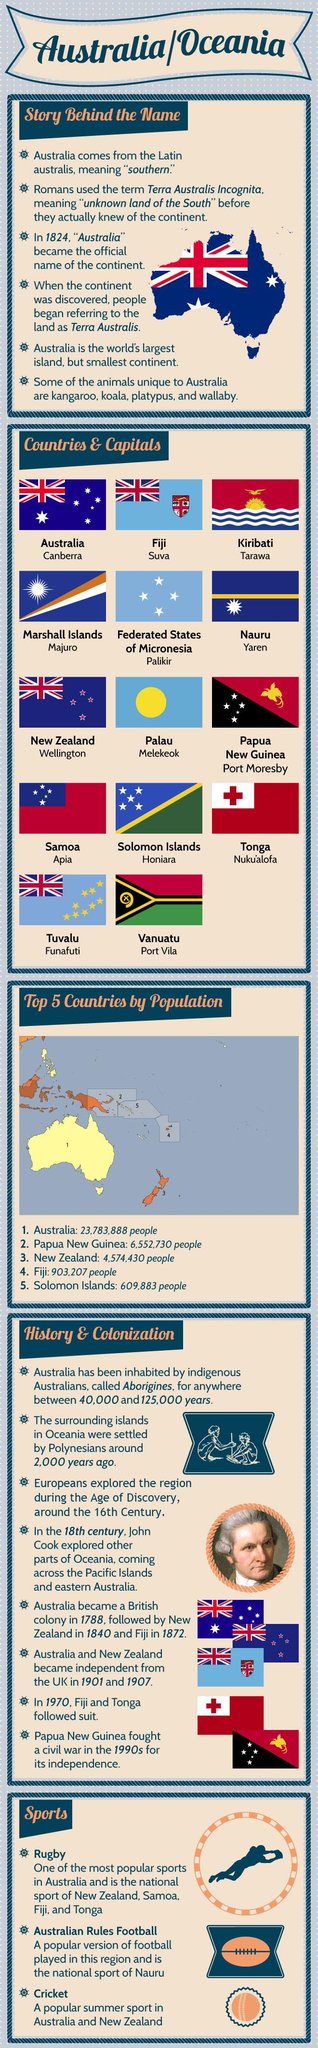Draw attention to some important aspects in this diagram. The capital of the Federated States of Micronesia is Palikir. According to the most recent data, the total population of Fiji and Solomon Islands is approximately 1,513,090. On July 1st, 1970, Fiji and Tonga both declared their independence from British rule. The independence of New Zealand was declared on the year 1907. The capital of Palau is Melekeok. 